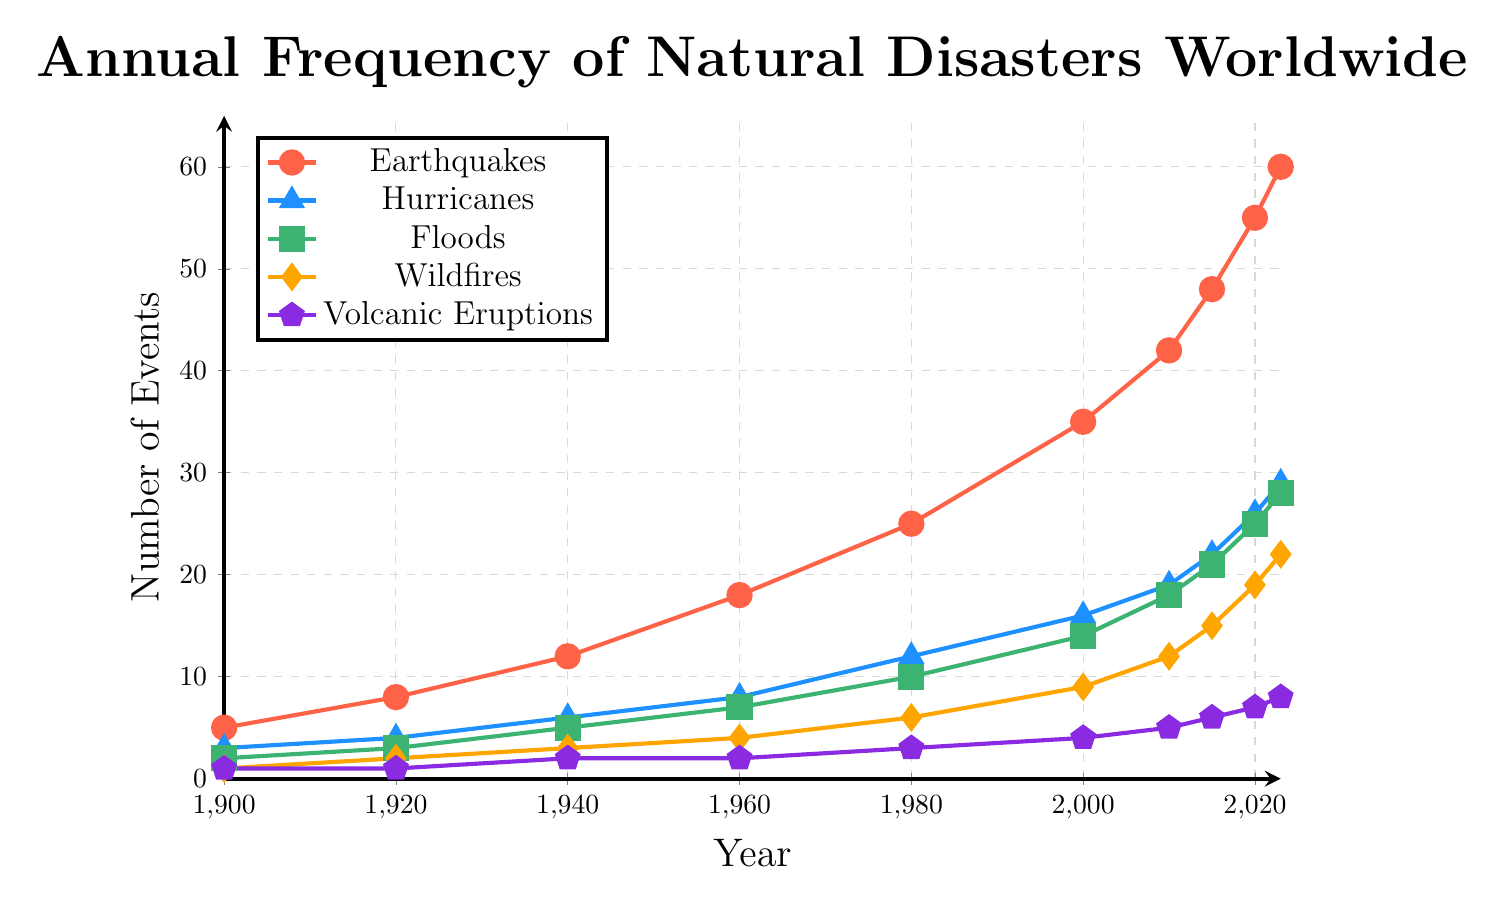What type of natural disaster had the highest frequency in 2023? Look at the endpoints of each line at the year 2023 and identify which one is the highest. Earthquakes end at 60, which is higher than any other disaster type in 2023.
Answer: Earthquakes How many more earthquakes than floods were there in 1940? Note the frequency of earthquakes in 1940 is 12 and the frequency of floods is 5. Subtract the number of floods from earthquakes (12 - 5).
Answer: 7 Which natural disaster showed the largest increase from 1900 to 2023? Compare the starting and ending values of each disaster type from 1900 to 2023: Earthquakes (60 - 5 = 55 increase), Hurricanes (29 - 3 = 26 increase), Floods (28 - 2 = 26 increase), Wildfires (22 - 1 = 21 increase), Volcanic Eruptions (8 - 1 = 7 increase). The largest difference is for Earthquakes with an increase of 55.
Answer: Earthquakes Which two natural disasters had an equal frequency in 1920? Identify the disaster types with the same value in 1920. Volcanic Eruptions and Wildfires both have a frequency of 1 in 1920.
Answer: Volcanic Eruptions, Wildfires Between 2000 and 2010, what was the average increase per year for wildfires? Wildfires in 2000 were 9 and in 2010 were 12. Calculate the increase (12 - 9 = 3) and then divide by the number of years (3 / 10 = 0.3).
Answer: 0.3 per year Which type of natural disaster had its highest peak at 2020? Check the endpoints for frequencies at 2020. Earthquakes are at 55 in 2020, which is the highest among all disasters listed for that year.
Answer: Earthquakes During which period did hurricanes show the fastest rate of increase? Compare the slopes (difference over years) of the hurricane line segments. Notably, from 2010 to 2023 (29 - 19) hurricanes increased by 10 in 13 years, whereas the period between other points shows smaller values.
Answer: 2010-2023 In 1960, how do the frequencies of earthquakes and hurricanes compare? Identify the values for earthquakes and hurricanes in 1960. Earthquakes are at 18 and hurricanes are at 8. Comparing, earthquakes are higher.
Answer: Earthquakes are higher What is the sum of all natural disaster frequencies in 2000? Sum the values of each type of disaster in 2000: Earthquakes (35), Hurricanes (16), Floods (14), Wildfires (9), Volcanic Eruptions (4). The total is 35 + 16 + 14 + 9 + 4 = 78.
Answer: 78 Which disaster had the least increase between 2015 and 2023? Calculate the increases between 2015 and 2023 for each: Earthquakes (60 - 48 = 12), Hurricanes (29 - 22 = 7), Floods (28 - 21 = 7), Wildfires (22 - 15 = 7), Volcanic Eruptions (8 - 6 = 2). Volcanic Eruptions had the smallest increase of 2.
Answer: Volcanic Eruptions 